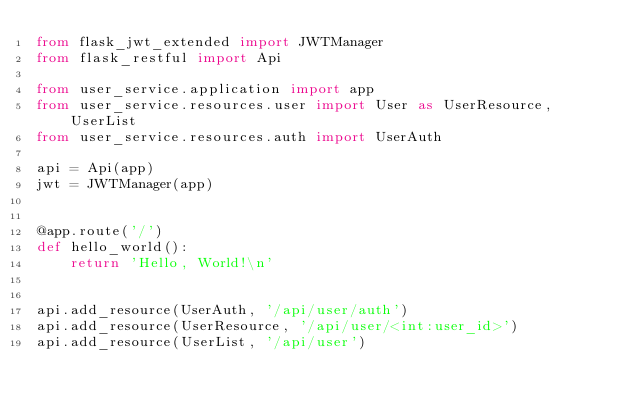<code> <loc_0><loc_0><loc_500><loc_500><_Python_>from flask_jwt_extended import JWTManager
from flask_restful import Api

from user_service.application import app
from user_service.resources.user import User as UserResource, UserList
from user_service.resources.auth import UserAuth

api = Api(app)
jwt = JWTManager(app)


@app.route('/')
def hello_world():
    return 'Hello, World!\n'


api.add_resource(UserAuth, '/api/user/auth')
api.add_resource(UserResource, '/api/user/<int:user_id>')
api.add_resource(UserList, '/api/user')
</code> 